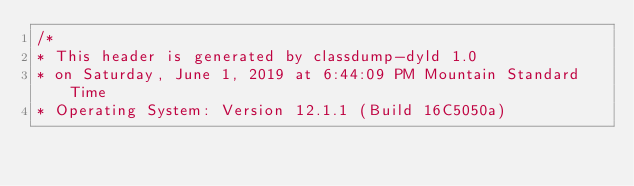<code> <loc_0><loc_0><loc_500><loc_500><_C_>/*
* This header is generated by classdump-dyld 1.0
* on Saturday, June 1, 2019 at 6:44:09 PM Mountain Standard Time
* Operating System: Version 12.1.1 (Build 16C5050a)</code> 